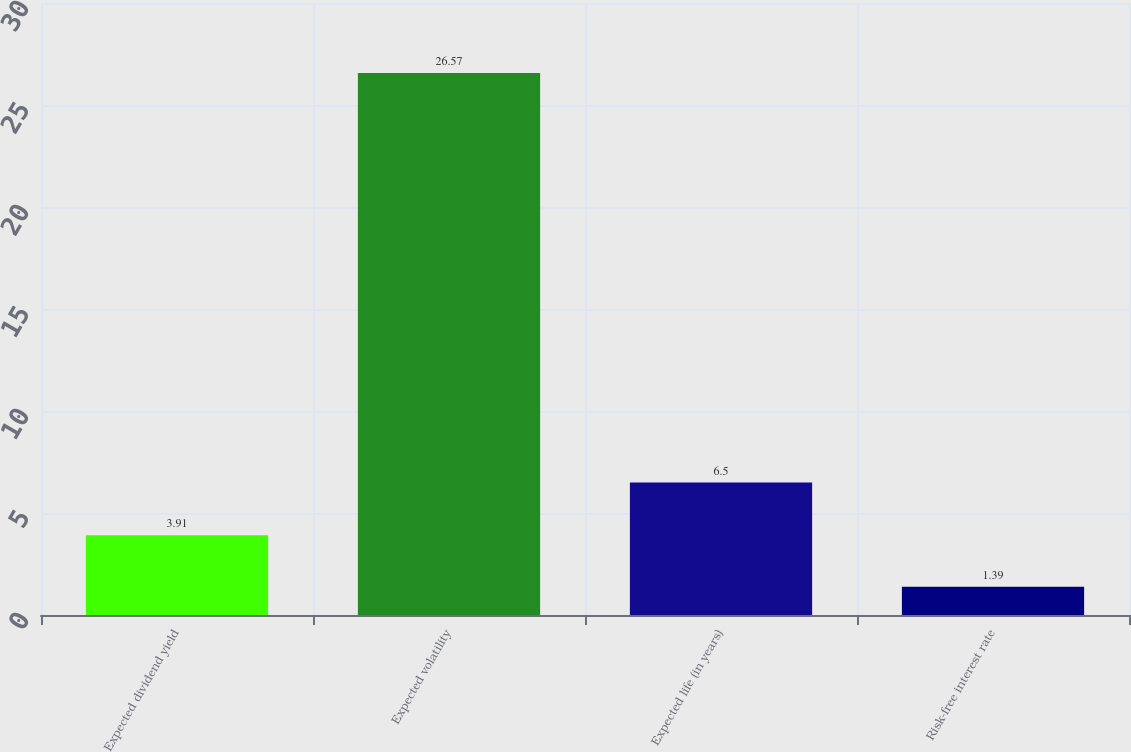<chart> <loc_0><loc_0><loc_500><loc_500><bar_chart><fcel>Expected dividend yield<fcel>Expected volatility<fcel>Expected life (in years)<fcel>Risk-free interest rate<nl><fcel>3.91<fcel>26.57<fcel>6.5<fcel>1.39<nl></chart> 